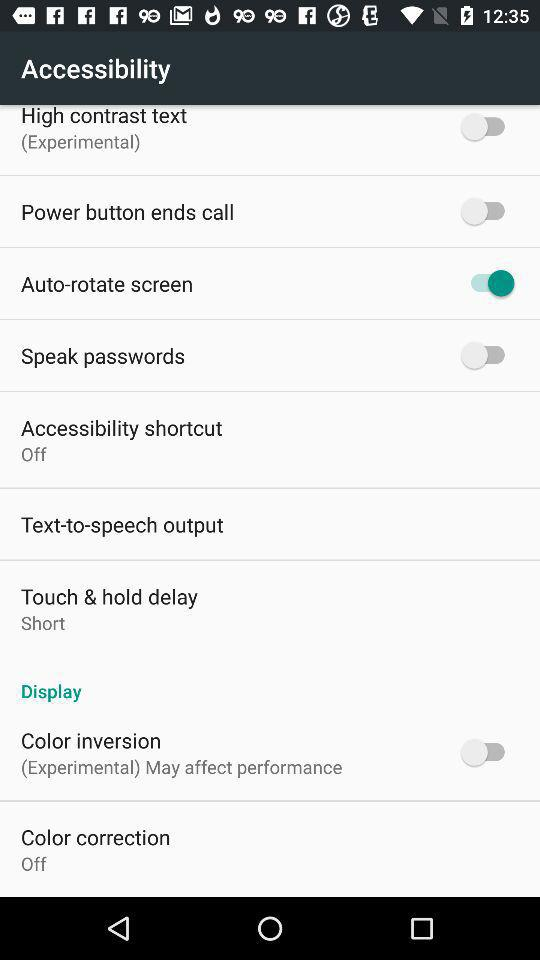What is the setting for the touch and hold delay? The setting is "Short". 